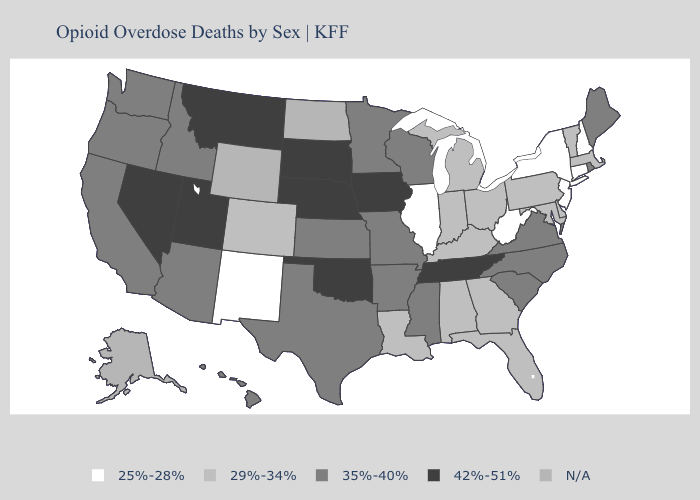Among the states that border Virginia , which have the lowest value?
Answer briefly. West Virginia. What is the lowest value in states that border Pennsylvania?
Concise answer only. 25%-28%. What is the value of Idaho?
Keep it brief. 35%-40%. Which states hav the highest value in the West?
Concise answer only. Montana, Nevada, Utah. What is the value of Maine?
Give a very brief answer. 35%-40%. Does Vermont have the lowest value in the Northeast?
Short answer required. No. Is the legend a continuous bar?
Concise answer only. No. Name the states that have a value in the range 29%-34%?
Concise answer only. Alabama, Colorado, Delaware, Florida, Georgia, Indiana, Kentucky, Louisiana, Maryland, Massachusetts, Michigan, Ohio, Pennsylvania, Vermont. Does New Hampshire have the lowest value in the Northeast?
Concise answer only. Yes. Which states have the lowest value in the USA?
Keep it brief. Connecticut, Illinois, New Hampshire, New Jersey, New Mexico, New York, West Virginia. Among the states that border Utah , which have the lowest value?
Quick response, please. New Mexico. Name the states that have a value in the range 25%-28%?
Give a very brief answer. Connecticut, Illinois, New Hampshire, New Jersey, New Mexico, New York, West Virginia. What is the value of Georgia?
Quick response, please. 29%-34%. Does the map have missing data?
Quick response, please. Yes. 